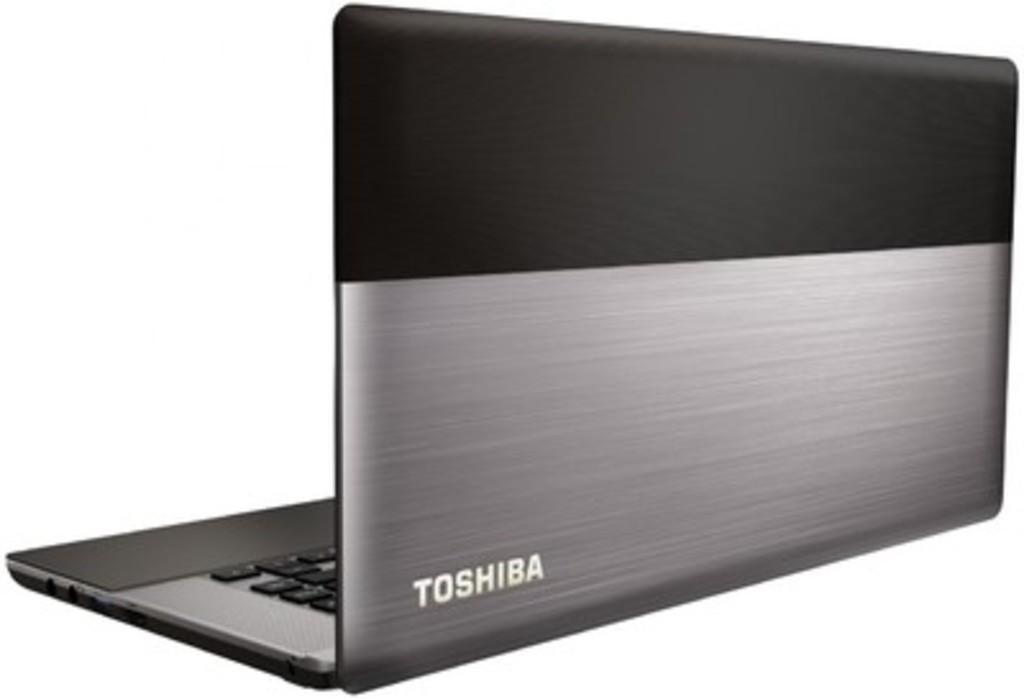Could you give a brief overview of what you see in this image? In this image there is a laptop. 